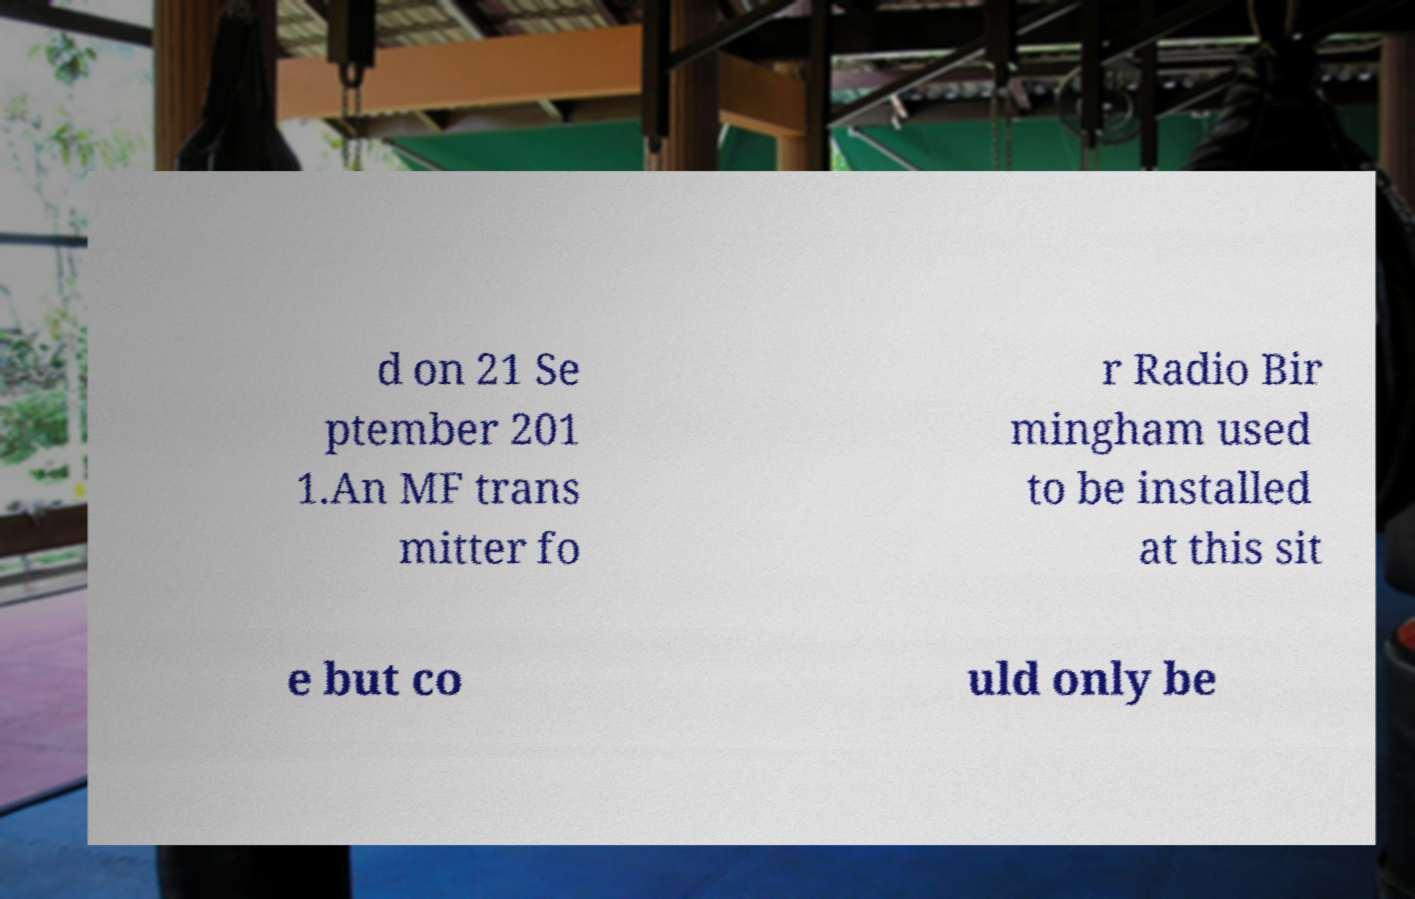Could you extract and type out the text from this image? d on 21 Se ptember 201 1.An MF trans mitter fo r Radio Bir mingham used to be installed at this sit e but co uld only be 